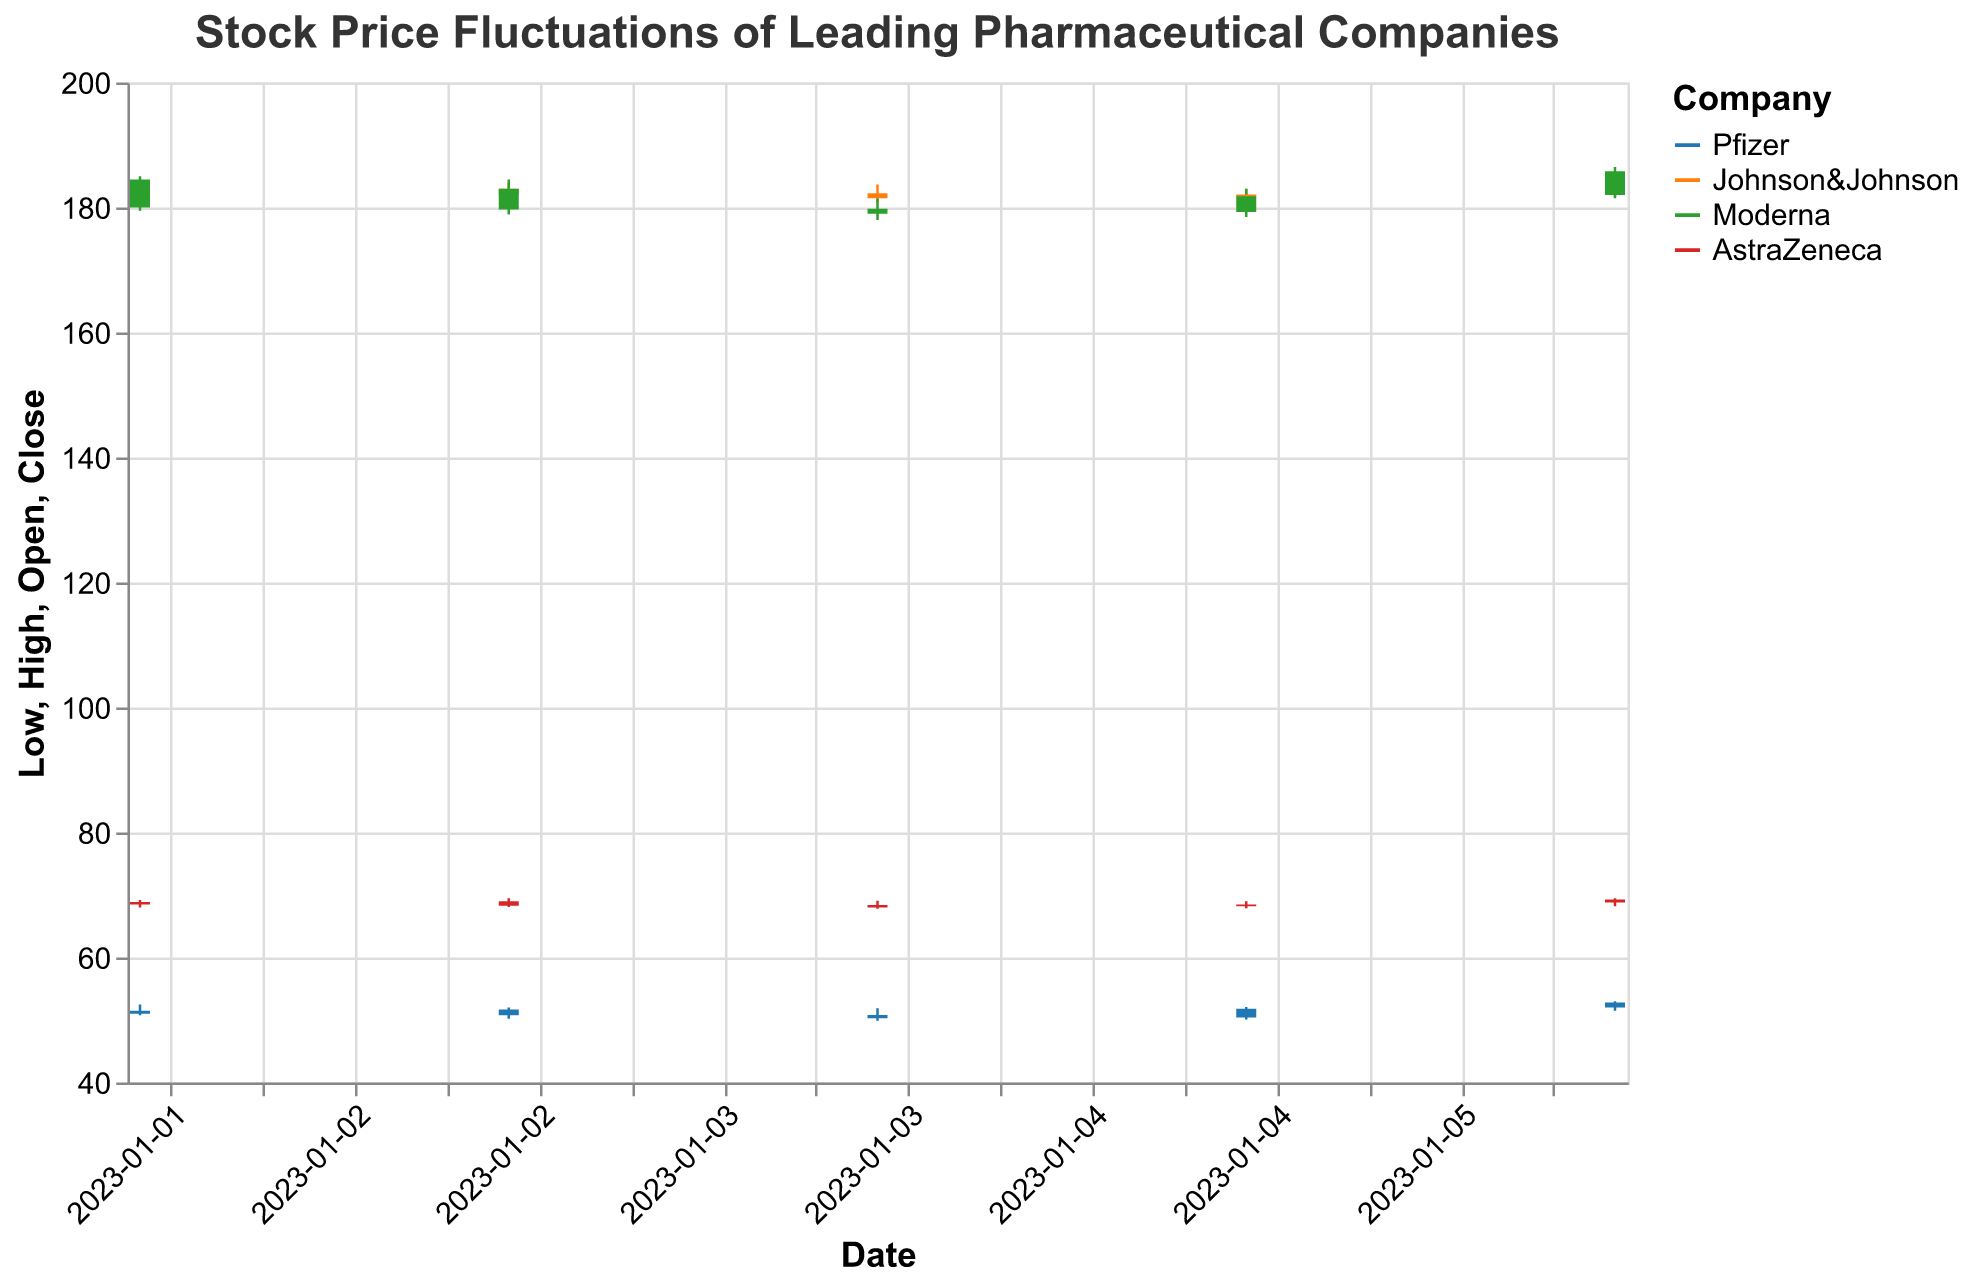What is the title of the figure? The title is typically displayed at the top of the figure and provides an overview of what the figure represents.
Answer: Stock Price Fluctuations of Leading Pharmaceutical Companies What date had the highest closing price for Pfizer? Look for the highest "Close" value under the Pfizer data and identify the corresponding date. The highest close for Pfizer is 52.80 on 2023-01-06.
Answer: 2023-01-06 Which company showed the lowest volume of trades on January 2, 2023? Compare the "Volume" values for each company on the specified date. AstraZeneca had the lowest volume with 3,200,000.
Answer: AstraZeneca What was the opening price of Johnson&Johnson on January 4, 2023? Refer to the "Open" price for Johnson&Johnson on the specified date. The opening price of Johnson&Johnson on 2023-01-04 was 182.30.
Answer: 182.30 Compare the closing prices of Moderna on January 3 and January 6, 2023. Which day had a higher closing price? Compare the "Close" values for Moderna on the specified dates. January 6 had a higher closing price (185.80) compared to January 3 (179.70).
Answer: January 6 How many days did AstraZeneca have a closing price greater than its opening price? Count the number of days when the "Close" value is greater than the "Open" value for AstraZeneca. AstraZeneca had a closing price greater than its opening price on January 2 and January 6.
Answer: 2 What was the range of the stock price (High - Low) for Pfizer on January 4, 2023? Calculate the difference between the "High" and "Low" values for Pfizer on the specified date. The range is 51.90 - 49.90 = 2.00.
Answer: 2.00 Which company had the highest trading volume on January 5, 2023? Compare the "Volume" values for each company on the specified date. Pfizer had the highest trading volume with 8,700,000.
Answer: Pfizer Did Moderna's stock price increase or decrease from January 2 to January 3, 2023? Compare the "Close" values for Moderna on the specified dates. The stock price decreased from 184.50 on January 2 to 179.70 on January 3.
Answer: Decrease What was the closing price trend for Johnson&Johnson from January 3 to January 6, 2023? Observe the "Close" values for Johnson&Johnson over the specified period to identify the trend. Johnson&Johnson's closing prices showed an overall increasing trend from 182.00 on January 3 to 183.90 on January 6.
Answer: Increasing 